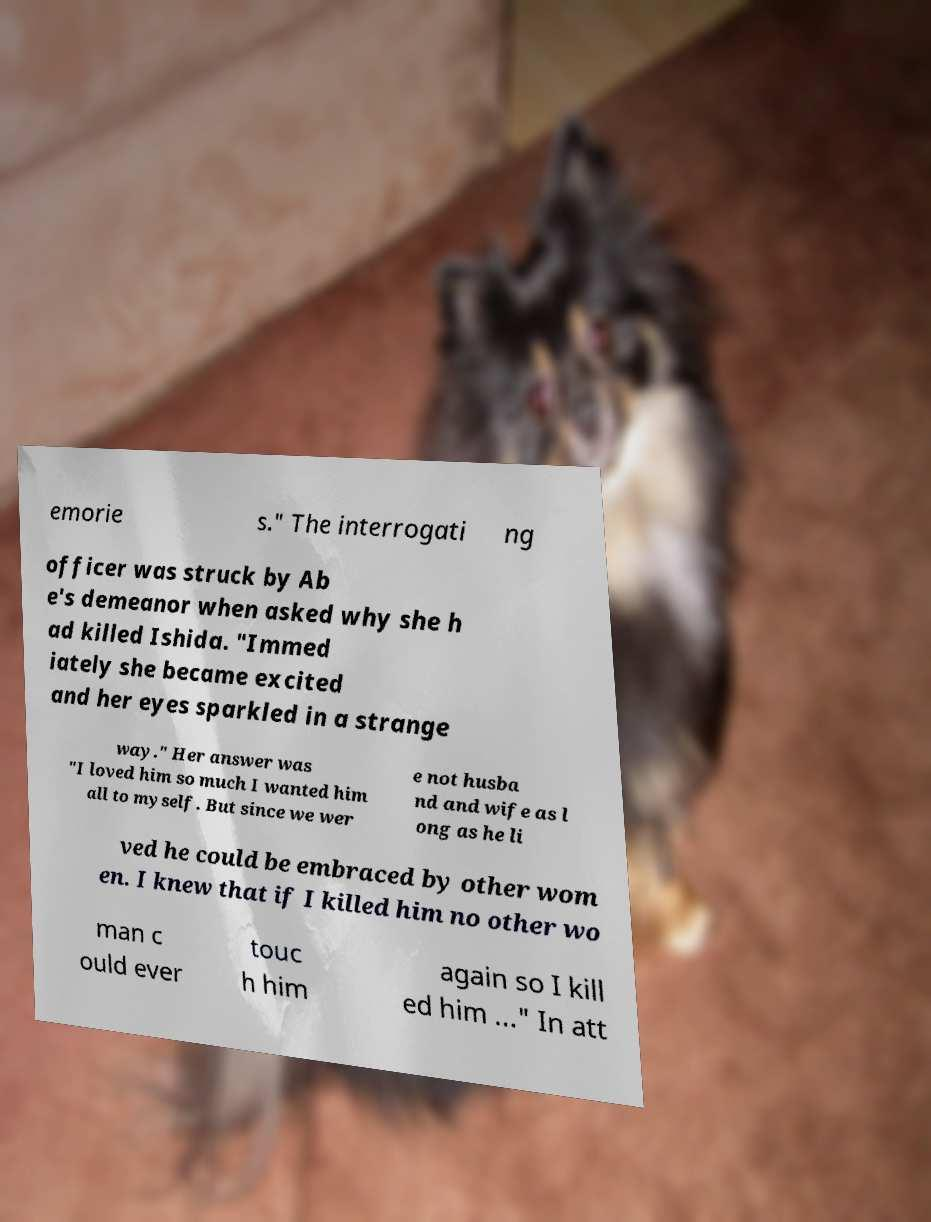Could you assist in decoding the text presented in this image and type it out clearly? emorie s." The interrogati ng officer was struck by Ab e's demeanor when asked why she h ad killed Ishida. "Immed iately she became excited and her eyes sparkled in a strange way." Her answer was "I loved him so much I wanted him all to myself. But since we wer e not husba nd and wife as l ong as he li ved he could be embraced by other wom en. I knew that if I killed him no other wo man c ould ever touc h him again so I kill ed him ..." In att 